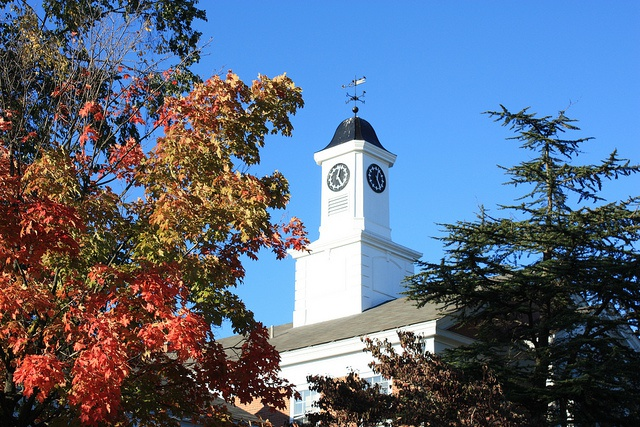Describe the objects in this image and their specific colors. I can see clock in black, navy, gray, and blue tones and clock in black, white, gray, and darkgray tones in this image. 